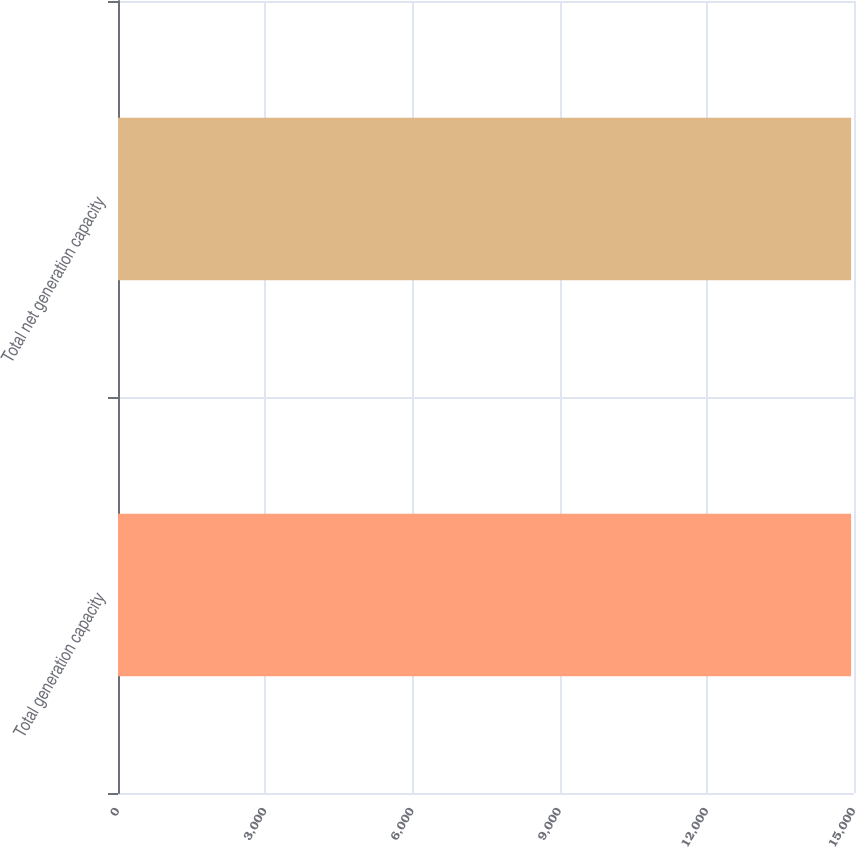<chart> <loc_0><loc_0><loc_500><loc_500><bar_chart><fcel>Total generation capacity<fcel>Total net generation capacity<nl><fcel>14941<fcel>14941.1<nl></chart> 